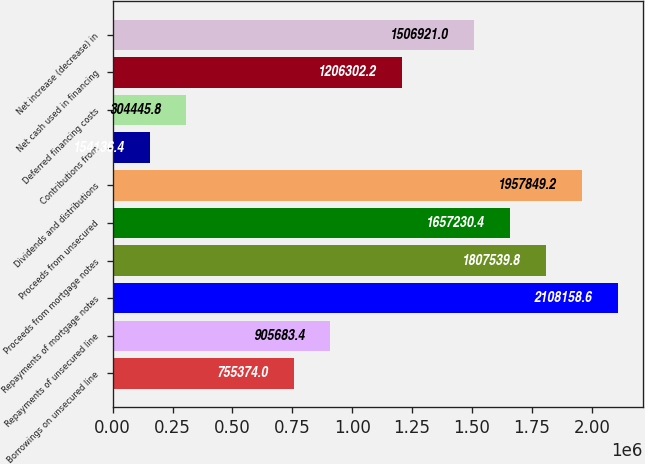<chart> <loc_0><loc_0><loc_500><loc_500><bar_chart><fcel>Borrowings on unsecured line<fcel>Repayments of unsecured line<fcel>Repayments of mortgage notes<fcel>Proceeds from mortgage notes<fcel>Proceeds from unsecured<fcel>Dividends and distributions<fcel>Contributions from<fcel>Deferred financing costs<fcel>Net cash used in financing<fcel>Net increase (decrease) in<nl><fcel>755374<fcel>905683<fcel>2.10816e+06<fcel>1.80754e+06<fcel>1.65723e+06<fcel>1.95785e+06<fcel>154136<fcel>304446<fcel>1.2063e+06<fcel>1.50692e+06<nl></chart> 